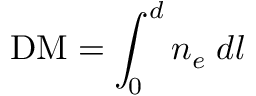<formula> <loc_0><loc_0><loc_500><loc_500>D M = \int _ { 0 } ^ { d } { n _ { e } \, d l }</formula> 